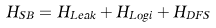Convert formula to latex. <formula><loc_0><loc_0><loc_500><loc_500>H _ { S B } = H _ { L e a k } + H _ { L o g i } + H _ { D F S }</formula> 